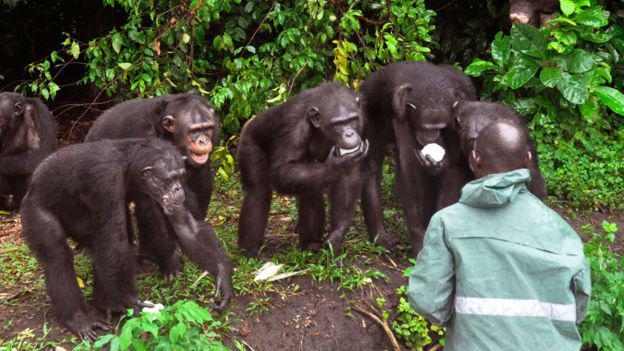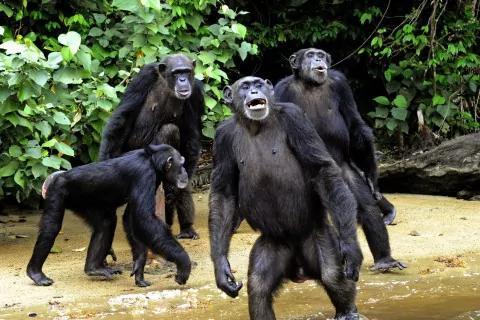The first image is the image on the left, the second image is the image on the right. Examine the images to the left and right. Is the description "Each image shows one person interacting with at least one chimp, and one image shows a black man with his hand on a chimp's head." accurate? Answer yes or no. No. The first image is the image on the left, the second image is the image on the right. Considering the images on both sides, is "There is at least four chimpanzees in the right image." valid? Answer yes or no. Yes. 